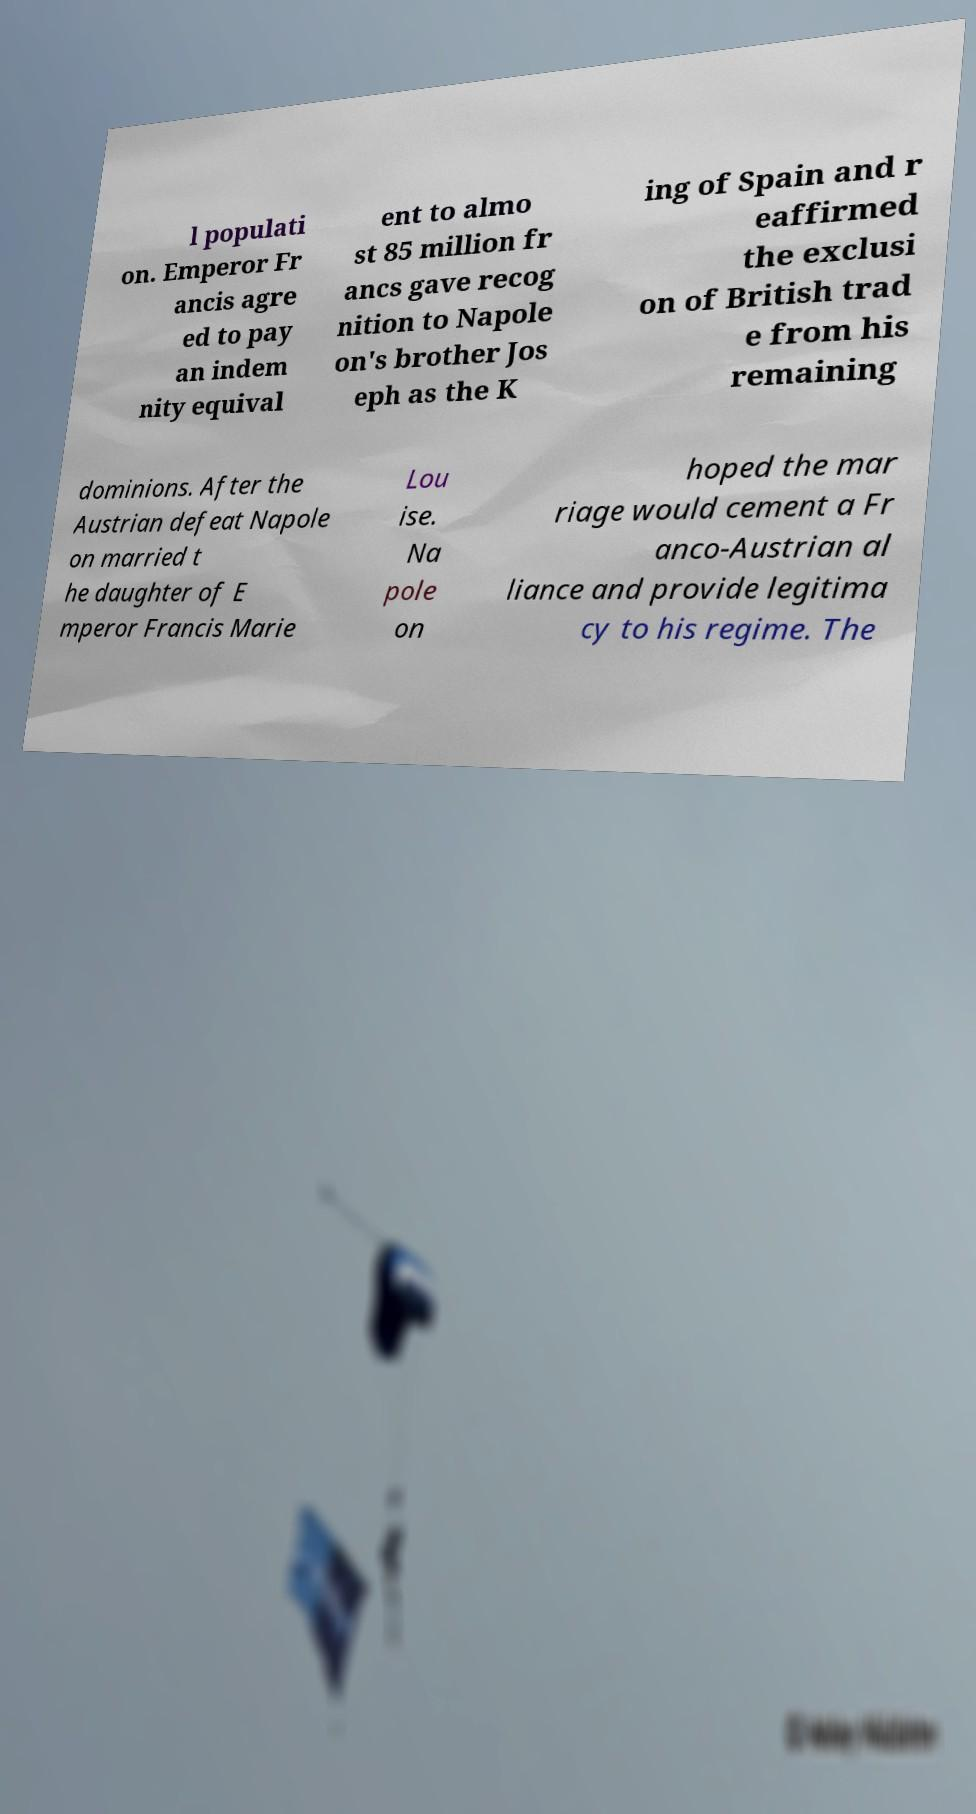Please identify and transcribe the text found in this image. l populati on. Emperor Fr ancis agre ed to pay an indem nity equival ent to almo st 85 million fr ancs gave recog nition to Napole on's brother Jos eph as the K ing of Spain and r eaffirmed the exclusi on of British trad e from his remaining dominions. After the Austrian defeat Napole on married t he daughter of E mperor Francis Marie Lou ise. Na pole on hoped the mar riage would cement a Fr anco-Austrian al liance and provide legitima cy to his regime. The 